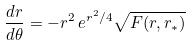Convert formula to latex. <formula><loc_0><loc_0><loc_500><loc_500>\frac { d r } { d \theta } = - r ^ { 2 } \, e ^ { r ^ { 2 } / 4 } \sqrt { F ( r , r _ { * } ) }</formula> 